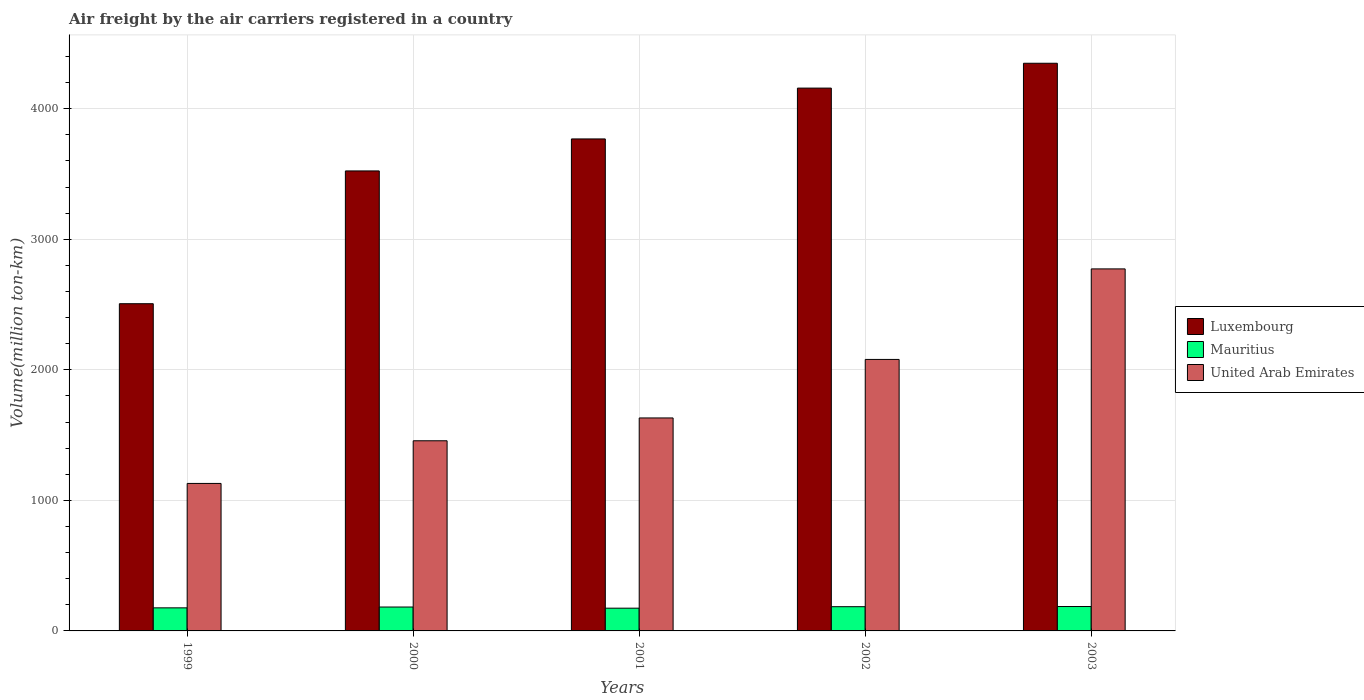How many bars are there on the 5th tick from the left?
Provide a succinct answer. 3. How many bars are there on the 4th tick from the right?
Make the answer very short. 3. In how many cases, is the number of bars for a given year not equal to the number of legend labels?
Make the answer very short. 0. What is the volume of the air carriers in Luxembourg in 1999?
Your response must be concise. 2506.1. Across all years, what is the maximum volume of the air carriers in United Arab Emirates?
Offer a very short reply. 2772.74. Across all years, what is the minimum volume of the air carriers in United Arab Emirates?
Give a very brief answer. 1129.7. In which year was the volume of the air carriers in Mauritius maximum?
Make the answer very short. 2003. In which year was the volume of the air carriers in United Arab Emirates minimum?
Make the answer very short. 1999. What is the total volume of the air carriers in United Arab Emirates in the graph?
Your answer should be compact. 9069.29. What is the difference between the volume of the air carriers in Mauritius in 2000 and that in 2002?
Provide a short and direct response. -2.59. What is the difference between the volume of the air carriers in Mauritius in 2003 and the volume of the air carriers in United Arab Emirates in 2002?
Give a very brief answer. -1892.53. What is the average volume of the air carriers in United Arab Emirates per year?
Provide a short and direct response. 1813.86. In the year 2001, what is the difference between the volume of the air carriers in Luxembourg and volume of the air carriers in Mauritius?
Your response must be concise. 3593.96. In how many years, is the volume of the air carriers in Luxembourg greater than 2800 million ton-km?
Your answer should be compact. 4. What is the ratio of the volume of the air carriers in Luxembourg in 2000 to that in 2002?
Ensure brevity in your answer.  0.85. Is the difference between the volume of the air carriers in Luxembourg in 2000 and 2003 greater than the difference between the volume of the air carriers in Mauritius in 2000 and 2003?
Offer a terse response. No. What is the difference between the highest and the second highest volume of the air carriers in Luxembourg?
Give a very brief answer. 190.27. What is the difference between the highest and the lowest volume of the air carriers in Mauritius?
Provide a short and direct response. 12.58. What does the 3rd bar from the left in 1999 represents?
Offer a very short reply. United Arab Emirates. What does the 3rd bar from the right in 2001 represents?
Offer a very short reply. Luxembourg. How many bars are there?
Keep it short and to the point. 15. Are all the bars in the graph horizontal?
Offer a very short reply. No. Are the values on the major ticks of Y-axis written in scientific E-notation?
Keep it short and to the point. No. Where does the legend appear in the graph?
Your answer should be compact. Center right. How are the legend labels stacked?
Make the answer very short. Vertical. What is the title of the graph?
Make the answer very short. Air freight by the air carriers registered in a country. Does "Latin America(developing only)" appear as one of the legend labels in the graph?
Provide a succinct answer. No. What is the label or title of the Y-axis?
Offer a terse response. Volume(million ton-km). What is the Volume(million ton-km) of Luxembourg in 1999?
Your answer should be compact. 2506.1. What is the Volume(million ton-km) of Mauritius in 1999?
Your answer should be very brief. 176.7. What is the Volume(million ton-km) in United Arab Emirates in 1999?
Make the answer very short. 1129.7. What is the Volume(million ton-km) of Luxembourg in 2000?
Give a very brief answer. 3523.14. What is the Volume(million ton-km) in Mauritius in 2000?
Make the answer very short. 182.98. What is the Volume(million ton-km) in United Arab Emirates in 2000?
Keep it short and to the point. 1456.35. What is the Volume(million ton-km) of Luxembourg in 2001?
Offer a very short reply. 3768.19. What is the Volume(million ton-km) of Mauritius in 2001?
Keep it short and to the point. 174.23. What is the Volume(million ton-km) in United Arab Emirates in 2001?
Make the answer very short. 1631.16. What is the Volume(million ton-km) of Luxembourg in 2002?
Your answer should be very brief. 4157.52. What is the Volume(million ton-km) in Mauritius in 2002?
Offer a very short reply. 185.57. What is the Volume(million ton-km) in United Arab Emirates in 2002?
Give a very brief answer. 2079.34. What is the Volume(million ton-km) in Luxembourg in 2003?
Offer a very short reply. 4347.78. What is the Volume(million ton-km) in Mauritius in 2003?
Your answer should be compact. 186.81. What is the Volume(million ton-km) in United Arab Emirates in 2003?
Give a very brief answer. 2772.74. Across all years, what is the maximum Volume(million ton-km) of Luxembourg?
Your answer should be very brief. 4347.78. Across all years, what is the maximum Volume(million ton-km) in Mauritius?
Your answer should be very brief. 186.81. Across all years, what is the maximum Volume(million ton-km) in United Arab Emirates?
Offer a terse response. 2772.74. Across all years, what is the minimum Volume(million ton-km) of Luxembourg?
Keep it short and to the point. 2506.1. Across all years, what is the minimum Volume(million ton-km) in Mauritius?
Your answer should be compact. 174.23. Across all years, what is the minimum Volume(million ton-km) in United Arab Emirates?
Ensure brevity in your answer.  1129.7. What is the total Volume(million ton-km) of Luxembourg in the graph?
Keep it short and to the point. 1.83e+04. What is the total Volume(million ton-km) of Mauritius in the graph?
Give a very brief answer. 906.29. What is the total Volume(million ton-km) of United Arab Emirates in the graph?
Give a very brief answer. 9069.29. What is the difference between the Volume(million ton-km) of Luxembourg in 1999 and that in 2000?
Provide a succinct answer. -1017.04. What is the difference between the Volume(million ton-km) in Mauritius in 1999 and that in 2000?
Your response must be concise. -6.28. What is the difference between the Volume(million ton-km) of United Arab Emirates in 1999 and that in 2000?
Ensure brevity in your answer.  -326.65. What is the difference between the Volume(million ton-km) in Luxembourg in 1999 and that in 2001?
Give a very brief answer. -1262.09. What is the difference between the Volume(million ton-km) in Mauritius in 1999 and that in 2001?
Provide a short and direct response. 2.47. What is the difference between the Volume(million ton-km) of United Arab Emirates in 1999 and that in 2001?
Offer a very short reply. -501.46. What is the difference between the Volume(million ton-km) in Luxembourg in 1999 and that in 2002?
Provide a succinct answer. -1651.41. What is the difference between the Volume(million ton-km) in Mauritius in 1999 and that in 2002?
Ensure brevity in your answer.  -8.87. What is the difference between the Volume(million ton-km) of United Arab Emirates in 1999 and that in 2002?
Give a very brief answer. -949.64. What is the difference between the Volume(million ton-km) in Luxembourg in 1999 and that in 2003?
Your answer should be very brief. -1841.68. What is the difference between the Volume(million ton-km) of Mauritius in 1999 and that in 2003?
Your answer should be very brief. -10.11. What is the difference between the Volume(million ton-km) in United Arab Emirates in 1999 and that in 2003?
Offer a very short reply. -1643.04. What is the difference between the Volume(million ton-km) in Luxembourg in 2000 and that in 2001?
Keep it short and to the point. -245.04. What is the difference between the Volume(million ton-km) of Mauritius in 2000 and that in 2001?
Offer a terse response. 8.76. What is the difference between the Volume(million ton-km) in United Arab Emirates in 2000 and that in 2001?
Your answer should be very brief. -174.81. What is the difference between the Volume(million ton-km) of Luxembourg in 2000 and that in 2002?
Your answer should be compact. -634.37. What is the difference between the Volume(million ton-km) in Mauritius in 2000 and that in 2002?
Provide a succinct answer. -2.59. What is the difference between the Volume(million ton-km) of United Arab Emirates in 2000 and that in 2002?
Provide a short and direct response. -622.99. What is the difference between the Volume(million ton-km) of Luxembourg in 2000 and that in 2003?
Your answer should be very brief. -824.64. What is the difference between the Volume(million ton-km) in Mauritius in 2000 and that in 2003?
Your answer should be compact. -3.83. What is the difference between the Volume(million ton-km) in United Arab Emirates in 2000 and that in 2003?
Ensure brevity in your answer.  -1316.39. What is the difference between the Volume(million ton-km) in Luxembourg in 2001 and that in 2002?
Your answer should be compact. -389.33. What is the difference between the Volume(million ton-km) of Mauritius in 2001 and that in 2002?
Provide a short and direct response. -11.35. What is the difference between the Volume(million ton-km) of United Arab Emirates in 2001 and that in 2002?
Provide a succinct answer. -448.17. What is the difference between the Volume(million ton-km) in Luxembourg in 2001 and that in 2003?
Make the answer very short. -579.59. What is the difference between the Volume(million ton-km) of Mauritius in 2001 and that in 2003?
Ensure brevity in your answer.  -12.58. What is the difference between the Volume(million ton-km) of United Arab Emirates in 2001 and that in 2003?
Your response must be concise. -1141.58. What is the difference between the Volume(million ton-km) in Luxembourg in 2002 and that in 2003?
Provide a short and direct response. -190.27. What is the difference between the Volume(million ton-km) of Mauritius in 2002 and that in 2003?
Ensure brevity in your answer.  -1.24. What is the difference between the Volume(million ton-km) in United Arab Emirates in 2002 and that in 2003?
Offer a terse response. -693.4. What is the difference between the Volume(million ton-km) in Luxembourg in 1999 and the Volume(million ton-km) in Mauritius in 2000?
Give a very brief answer. 2323.12. What is the difference between the Volume(million ton-km) of Luxembourg in 1999 and the Volume(million ton-km) of United Arab Emirates in 2000?
Give a very brief answer. 1049.75. What is the difference between the Volume(million ton-km) in Mauritius in 1999 and the Volume(million ton-km) in United Arab Emirates in 2000?
Provide a short and direct response. -1279.65. What is the difference between the Volume(million ton-km) of Luxembourg in 1999 and the Volume(million ton-km) of Mauritius in 2001?
Your response must be concise. 2331.87. What is the difference between the Volume(million ton-km) of Luxembourg in 1999 and the Volume(million ton-km) of United Arab Emirates in 2001?
Offer a very short reply. 874.94. What is the difference between the Volume(million ton-km) of Mauritius in 1999 and the Volume(million ton-km) of United Arab Emirates in 2001?
Your answer should be very brief. -1454.46. What is the difference between the Volume(million ton-km) in Luxembourg in 1999 and the Volume(million ton-km) in Mauritius in 2002?
Your answer should be compact. 2320.53. What is the difference between the Volume(million ton-km) in Luxembourg in 1999 and the Volume(million ton-km) in United Arab Emirates in 2002?
Make the answer very short. 426.76. What is the difference between the Volume(million ton-km) in Mauritius in 1999 and the Volume(million ton-km) in United Arab Emirates in 2002?
Your answer should be compact. -1902.64. What is the difference between the Volume(million ton-km) of Luxembourg in 1999 and the Volume(million ton-km) of Mauritius in 2003?
Provide a succinct answer. 2319.29. What is the difference between the Volume(million ton-km) of Luxembourg in 1999 and the Volume(million ton-km) of United Arab Emirates in 2003?
Give a very brief answer. -266.64. What is the difference between the Volume(million ton-km) in Mauritius in 1999 and the Volume(million ton-km) in United Arab Emirates in 2003?
Your answer should be very brief. -2596.04. What is the difference between the Volume(million ton-km) in Luxembourg in 2000 and the Volume(million ton-km) in Mauritius in 2001?
Offer a terse response. 3348.92. What is the difference between the Volume(million ton-km) of Luxembourg in 2000 and the Volume(million ton-km) of United Arab Emirates in 2001?
Your answer should be compact. 1891.98. What is the difference between the Volume(million ton-km) in Mauritius in 2000 and the Volume(million ton-km) in United Arab Emirates in 2001?
Your answer should be compact. -1448.18. What is the difference between the Volume(million ton-km) in Luxembourg in 2000 and the Volume(million ton-km) in Mauritius in 2002?
Offer a very short reply. 3337.57. What is the difference between the Volume(million ton-km) of Luxembourg in 2000 and the Volume(million ton-km) of United Arab Emirates in 2002?
Your answer should be compact. 1443.8. What is the difference between the Volume(million ton-km) of Mauritius in 2000 and the Volume(million ton-km) of United Arab Emirates in 2002?
Give a very brief answer. -1896.36. What is the difference between the Volume(million ton-km) in Luxembourg in 2000 and the Volume(million ton-km) in Mauritius in 2003?
Provide a succinct answer. 3336.34. What is the difference between the Volume(million ton-km) of Luxembourg in 2000 and the Volume(million ton-km) of United Arab Emirates in 2003?
Make the answer very short. 750.4. What is the difference between the Volume(million ton-km) in Mauritius in 2000 and the Volume(million ton-km) in United Arab Emirates in 2003?
Ensure brevity in your answer.  -2589.76. What is the difference between the Volume(million ton-km) of Luxembourg in 2001 and the Volume(million ton-km) of Mauritius in 2002?
Keep it short and to the point. 3582.62. What is the difference between the Volume(million ton-km) of Luxembourg in 2001 and the Volume(million ton-km) of United Arab Emirates in 2002?
Provide a short and direct response. 1688.85. What is the difference between the Volume(million ton-km) of Mauritius in 2001 and the Volume(million ton-km) of United Arab Emirates in 2002?
Ensure brevity in your answer.  -1905.11. What is the difference between the Volume(million ton-km) of Luxembourg in 2001 and the Volume(million ton-km) of Mauritius in 2003?
Ensure brevity in your answer.  3581.38. What is the difference between the Volume(million ton-km) in Luxembourg in 2001 and the Volume(million ton-km) in United Arab Emirates in 2003?
Offer a very short reply. 995.45. What is the difference between the Volume(million ton-km) of Mauritius in 2001 and the Volume(million ton-km) of United Arab Emirates in 2003?
Make the answer very short. -2598.51. What is the difference between the Volume(million ton-km) in Luxembourg in 2002 and the Volume(million ton-km) in Mauritius in 2003?
Your response must be concise. 3970.71. What is the difference between the Volume(million ton-km) in Luxembourg in 2002 and the Volume(million ton-km) in United Arab Emirates in 2003?
Keep it short and to the point. 1384.78. What is the difference between the Volume(million ton-km) of Mauritius in 2002 and the Volume(million ton-km) of United Arab Emirates in 2003?
Provide a short and direct response. -2587.17. What is the average Volume(million ton-km) of Luxembourg per year?
Provide a short and direct response. 3660.55. What is the average Volume(million ton-km) of Mauritius per year?
Offer a terse response. 181.26. What is the average Volume(million ton-km) of United Arab Emirates per year?
Give a very brief answer. 1813.86. In the year 1999, what is the difference between the Volume(million ton-km) of Luxembourg and Volume(million ton-km) of Mauritius?
Your answer should be compact. 2329.4. In the year 1999, what is the difference between the Volume(million ton-km) of Luxembourg and Volume(million ton-km) of United Arab Emirates?
Provide a short and direct response. 1376.4. In the year 1999, what is the difference between the Volume(million ton-km) of Mauritius and Volume(million ton-km) of United Arab Emirates?
Offer a very short reply. -953. In the year 2000, what is the difference between the Volume(million ton-km) in Luxembourg and Volume(million ton-km) in Mauritius?
Offer a terse response. 3340.16. In the year 2000, what is the difference between the Volume(million ton-km) of Luxembourg and Volume(million ton-km) of United Arab Emirates?
Your answer should be very brief. 2066.79. In the year 2000, what is the difference between the Volume(million ton-km) of Mauritius and Volume(million ton-km) of United Arab Emirates?
Provide a succinct answer. -1273.37. In the year 2001, what is the difference between the Volume(million ton-km) of Luxembourg and Volume(million ton-km) of Mauritius?
Offer a terse response. 3593.96. In the year 2001, what is the difference between the Volume(million ton-km) of Luxembourg and Volume(million ton-km) of United Arab Emirates?
Your response must be concise. 2137.02. In the year 2001, what is the difference between the Volume(million ton-km) of Mauritius and Volume(million ton-km) of United Arab Emirates?
Provide a short and direct response. -1456.94. In the year 2002, what is the difference between the Volume(million ton-km) of Luxembourg and Volume(million ton-km) of Mauritius?
Provide a succinct answer. 3971.94. In the year 2002, what is the difference between the Volume(million ton-km) of Luxembourg and Volume(million ton-km) of United Arab Emirates?
Offer a very short reply. 2078.18. In the year 2002, what is the difference between the Volume(million ton-km) of Mauritius and Volume(million ton-km) of United Arab Emirates?
Give a very brief answer. -1893.77. In the year 2003, what is the difference between the Volume(million ton-km) in Luxembourg and Volume(million ton-km) in Mauritius?
Your answer should be compact. 4160.97. In the year 2003, what is the difference between the Volume(million ton-km) in Luxembourg and Volume(million ton-km) in United Arab Emirates?
Provide a succinct answer. 1575.04. In the year 2003, what is the difference between the Volume(million ton-km) in Mauritius and Volume(million ton-km) in United Arab Emirates?
Offer a terse response. -2585.93. What is the ratio of the Volume(million ton-km) in Luxembourg in 1999 to that in 2000?
Make the answer very short. 0.71. What is the ratio of the Volume(million ton-km) in Mauritius in 1999 to that in 2000?
Your response must be concise. 0.97. What is the ratio of the Volume(million ton-km) in United Arab Emirates in 1999 to that in 2000?
Your response must be concise. 0.78. What is the ratio of the Volume(million ton-km) of Luxembourg in 1999 to that in 2001?
Ensure brevity in your answer.  0.67. What is the ratio of the Volume(million ton-km) of Mauritius in 1999 to that in 2001?
Give a very brief answer. 1.01. What is the ratio of the Volume(million ton-km) in United Arab Emirates in 1999 to that in 2001?
Your answer should be very brief. 0.69. What is the ratio of the Volume(million ton-km) in Luxembourg in 1999 to that in 2002?
Your answer should be very brief. 0.6. What is the ratio of the Volume(million ton-km) of Mauritius in 1999 to that in 2002?
Ensure brevity in your answer.  0.95. What is the ratio of the Volume(million ton-km) of United Arab Emirates in 1999 to that in 2002?
Your answer should be very brief. 0.54. What is the ratio of the Volume(million ton-km) of Luxembourg in 1999 to that in 2003?
Provide a short and direct response. 0.58. What is the ratio of the Volume(million ton-km) in Mauritius in 1999 to that in 2003?
Give a very brief answer. 0.95. What is the ratio of the Volume(million ton-km) of United Arab Emirates in 1999 to that in 2003?
Make the answer very short. 0.41. What is the ratio of the Volume(million ton-km) in Luxembourg in 2000 to that in 2001?
Provide a succinct answer. 0.94. What is the ratio of the Volume(million ton-km) in Mauritius in 2000 to that in 2001?
Give a very brief answer. 1.05. What is the ratio of the Volume(million ton-km) of United Arab Emirates in 2000 to that in 2001?
Ensure brevity in your answer.  0.89. What is the ratio of the Volume(million ton-km) in Luxembourg in 2000 to that in 2002?
Your answer should be compact. 0.85. What is the ratio of the Volume(million ton-km) of United Arab Emirates in 2000 to that in 2002?
Your answer should be compact. 0.7. What is the ratio of the Volume(million ton-km) in Luxembourg in 2000 to that in 2003?
Keep it short and to the point. 0.81. What is the ratio of the Volume(million ton-km) in Mauritius in 2000 to that in 2003?
Ensure brevity in your answer.  0.98. What is the ratio of the Volume(million ton-km) in United Arab Emirates in 2000 to that in 2003?
Make the answer very short. 0.53. What is the ratio of the Volume(million ton-km) of Luxembourg in 2001 to that in 2002?
Provide a short and direct response. 0.91. What is the ratio of the Volume(million ton-km) of Mauritius in 2001 to that in 2002?
Offer a terse response. 0.94. What is the ratio of the Volume(million ton-km) in United Arab Emirates in 2001 to that in 2002?
Offer a terse response. 0.78. What is the ratio of the Volume(million ton-km) of Luxembourg in 2001 to that in 2003?
Provide a short and direct response. 0.87. What is the ratio of the Volume(million ton-km) in Mauritius in 2001 to that in 2003?
Provide a succinct answer. 0.93. What is the ratio of the Volume(million ton-km) in United Arab Emirates in 2001 to that in 2003?
Make the answer very short. 0.59. What is the ratio of the Volume(million ton-km) of Luxembourg in 2002 to that in 2003?
Offer a very short reply. 0.96. What is the ratio of the Volume(million ton-km) in United Arab Emirates in 2002 to that in 2003?
Offer a terse response. 0.75. What is the difference between the highest and the second highest Volume(million ton-km) of Luxembourg?
Keep it short and to the point. 190.27. What is the difference between the highest and the second highest Volume(million ton-km) in Mauritius?
Your response must be concise. 1.24. What is the difference between the highest and the second highest Volume(million ton-km) of United Arab Emirates?
Your answer should be very brief. 693.4. What is the difference between the highest and the lowest Volume(million ton-km) in Luxembourg?
Your answer should be compact. 1841.68. What is the difference between the highest and the lowest Volume(million ton-km) in Mauritius?
Keep it short and to the point. 12.58. What is the difference between the highest and the lowest Volume(million ton-km) of United Arab Emirates?
Your response must be concise. 1643.04. 